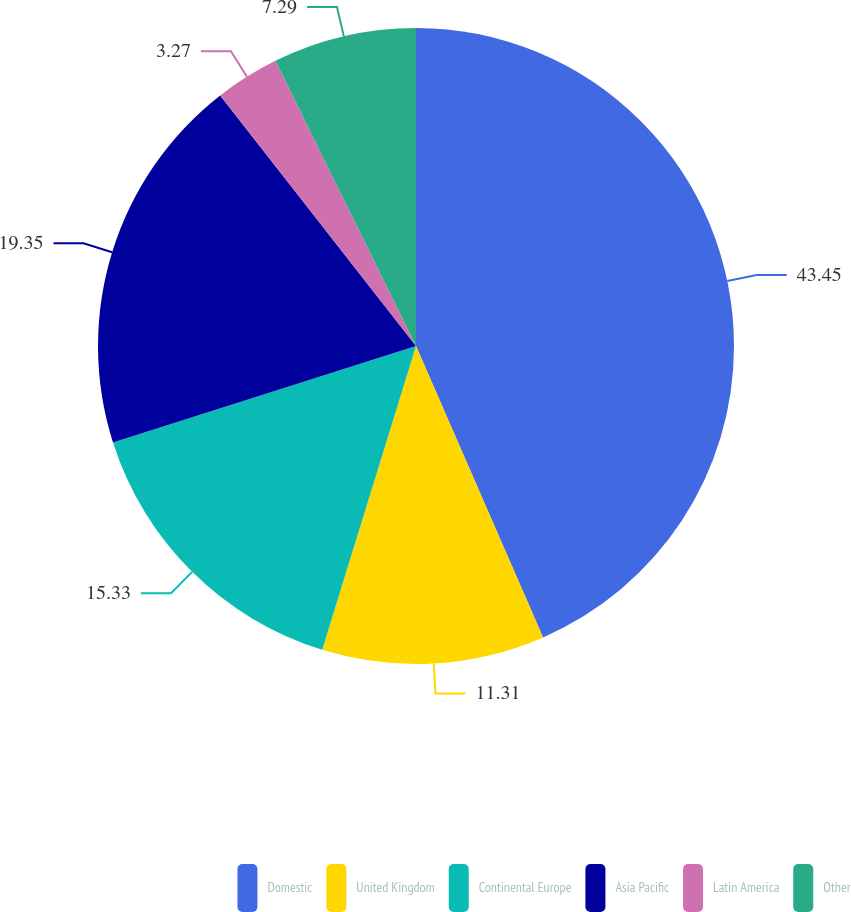Convert chart to OTSL. <chart><loc_0><loc_0><loc_500><loc_500><pie_chart><fcel>Domestic<fcel>United Kingdom<fcel>Continental Europe<fcel>Asia Pacific<fcel>Latin America<fcel>Other<nl><fcel>43.46%<fcel>11.31%<fcel>15.33%<fcel>19.35%<fcel>3.27%<fcel>7.29%<nl></chart> 